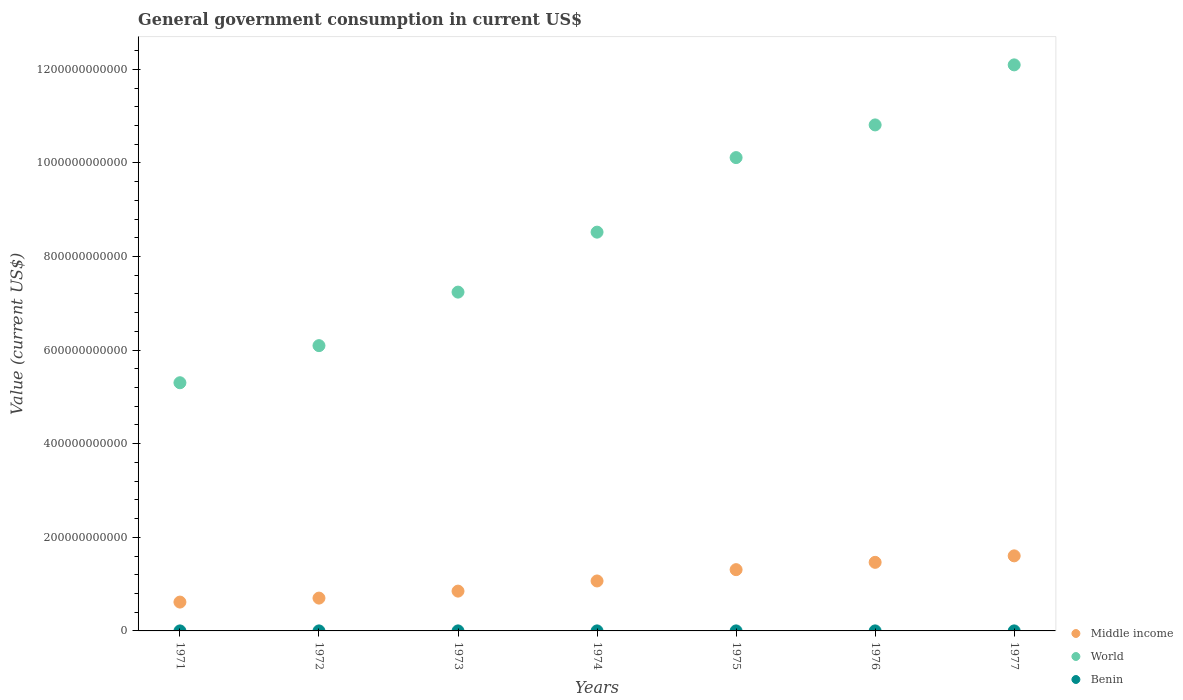How many different coloured dotlines are there?
Provide a short and direct response. 3. What is the government conusmption in Middle income in 1974?
Make the answer very short. 1.07e+11. Across all years, what is the maximum government conusmption in Benin?
Your answer should be very brief. 6.26e+07. Across all years, what is the minimum government conusmption in Middle income?
Give a very brief answer. 6.16e+1. In which year was the government conusmption in Middle income maximum?
Keep it short and to the point. 1977. What is the total government conusmption in World in the graph?
Keep it short and to the point. 6.02e+12. What is the difference between the government conusmption in Benin in 1974 and that in 1976?
Give a very brief answer. -1.22e+07. What is the difference between the government conusmption in Middle income in 1971 and the government conusmption in Benin in 1977?
Offer a very short reply. 6.16e+1. What is the average government conusmption in World per year?
Offer a terse response. 8.60e+11. In the year 1975, what is the difference between the government conusmption in Middle income and government conusmption in World?
Offer a very short reply. -8.80e+11. What is the ratio of the government conusmption in World in 1976 to that in 1977?
Your response must be concise. 0.89. Is the government conusmption in World in 1971 less than that in 1973?
Keep it short and to the point. Yes. What is the difference between the highest and the second highest government conusmption in World?
Make the answer very short. 1.28e+11. What is the difference between the highest and the lowest government conusmption in Benin?
Provide a short and direct response. 2.90e+07. Is the sum of the government conusmption in World in 1974 and 1976 greater than the maximum government conusmption in Middle income across all years?
Your answer should be very brief. Yes. Is it the case that in every year, the sum of the government conusmption in World and government conusmption in Benin  is greater than the government conusmption in Middle income?
Give a very brief answer. Yes. Does the government conusmption in Middle income monotonically increase over the years?
Offer a terse response. Yes. How many years are there in the graph?
Your response must be concise. 7. What is the difference between two consecutive major ticks on the Y-axis?
Your response must be concise. 2.00e+11. Where does the legend appear in the graph?
Offer a very short reply. Bottom right. How many legend labels are there?
Your answer should be compact. 3. How are the legend labels stacked?
Provide a short and direct response. Vertical. What is the title of the graph?
Give a very brief answer. General government consumption in current US$. What is the label or title of the X-axis?
Ensure brevity in your answer.  Years. What is the label or title of the Y-axis?
Ensure brevity in your answer.  Value (current US$). What is the Value (current US$) of Middle income in 1971?
Keep it short and to the point. 6.16e+1. What is the Value (current US$) of World in 1971?
Provide a succinct answer. 5.30e+11. What is the Value (current US$) in Benin in 1971?
Provide a succinct answer. 3.37e+07. What is the Value (current US$) of Middle income in 1972?
Your answer should be very brief. 7.01e+1. What is the Value (current US$) of World in 1972?
Provide a short and direct response. 6.10e+11. What is the Value (current US$) in Benin in 1972?
Ensure brevity in your answer.  4.16e+07. What is the Value (current US$) of Middle income in 1973?
Provide a succinct answer. 8.51e+1. What is the Value (current US$) of World in 1973?
Your answer should be compact. 7.24e+11. What is the Value (current US$) of Benin in 1973?
Your answer should be very brief. 5.02e+07. What is the Value (current US$) of Middle income in 1974?
Offer a very short reply. 1.07e+11. What is the Value (current US$) in World in 1974?
Provide a succinct answer. 8.52e+11. What is the Value (current US$) of Benin in 1974?
Make the answer very short. 4.78e+07. What is the Value (current US$) in Middle income in 1975?
Make the answer very short. 1.31e+11. What is the Value (current US$) in World in 1975?
Offer a terse response. 1.01e+12. What is the Value (current US$) in Benin in 1975?
Your response must be concise. 6.26e+07. What is the Value (current US$) of Middle income in 1976?
Your answer should be very brief. 1.47e+11. What is the Value (current US$) in World in 1976?
Offer a very short reply. 1.08e+12. What is the Value (current US$) of Benin in 1976?
Your answer should be compact. 6.00e+07. What is the Value (current US$) in Middle income in 1977?
Ensure brevity in your answer.  1.60e+11. What is the Value (current US$) in World in 1977?
Offer a very short reply. 1.21e+12. What is the Value (current US$) in Benin in 1977?
Provide a short and direct response. 6.23e+07. Across all years, what is the maximum Value (current US$) of Middle income?
Offer a terse response. 1.60e+11. Across all years, what is the maximum Value (current US$) in World?
Offer a terse response. 1.21e+12. Across all years, what is the maximum Value (current US$) of Benin?
Make the answer very short. 6.26e+07. Across all years, what is the minimum Value (current US$) in Middle income?
Your answer should be very brief. 6.16e+1. Across all years, what is the minimum Value (current US$) in World?
Ensure brevity in your answer.  5.30e+11. Across all years, what is the minimum Value (current US$) in Benin?
Offer a very short reply. 3.37e+07. What is the total Value (current US$) in Middle income in the graph?
Your response must be concise. 7.61e+11. What is the total Value (current US$) in World in the graph?
Provide a succinct answer. 6.02e+12. What is the total Value (current US$) in Benin in the graph?
Offer a terse response. 3.58e+08. What is the difference between the Value (current US$) in Middle income in 1971 and that in 1972?
Ensure brevity in your answer.  -8.50e+09. What is the difference between the Value (current US$) in World in 1971 and that in 1972?
Provide a succinct answer. -7.93e+1. What is the difference between the Value (current US$) in Benin in 1971 and that in 1972?
Keep it short and to the point. -7.96e+06. What is the difference between the Value (current US$) of Middle income in 1971 and that in 1973?
Your answer should be compact. -2.34e+1. What is the difference between the Value (current US$) in World in 1971 and that in 1973?
Offer a terse response. -1.94e+11. What is the difference between the Value (current US$) of Benin in 1971 and that in 1973?
Your response must be concise. -1.66e+07. What is the difference between the Value (current US$) of Middle income in 1971 and that in 1974?
Offer a terse response. -4.51e+1. What is the difference between the Value (current US$) of World in 1971 and that in 1974?
Provide a succinct answer. -3.22e+11. What is the difference between the Value (current US$) of Benin in 1971 and that in 1974?
Your response must be concise. -1.41e+07. What is the difference between the Value (current US$) of Middle income in 1971 and that in 1975?
Make the answer very short. -6.93e+1. What is the difference between the Value (current US$) of World in 1971 and that in 1975?
Your response must be concise. -4.81e+11. What is the difference between the Value (current US$) of Benin in 1971 and that in 1975?
Keep it short and to the point. -2.90e+07. What is the difference between the Value (current US$) in Middle income in 1971 and that in 1976?
Your answer should be compact. -8.49e+1. What is the difference between the Value (current US$) of World in 1971 and that in 1976?
Provide a short and direct response. -5.51e+11. What is the difference between the Value (current US$) in Benin in 1971 and that in 1976?
Your answer should be compact. -2.63e+07. What is the difference between the Value (current US$) in Middle income in 1971 and that in 1977?
Offer a terse response. -9.88e+1. What is the difference between the Value (current US$) in World in 1971 and that in 1977?
Your response must be concise. -6.79e+11. What is the difference between the Value (current US$) in Benin in 1971 and that in 1977?
Ensure brevity in your answer.  -2.87e+07. What is the difference between the Value (current US$) in Middle income in 1972 and that in 1973?
Your answer should be compact. -1.49e+1. What is the difference between the Value (current US$) in World in 1972 and that in 1973?
Your response must be concise. -1.14e+11. What is the difference between the Value (current US$) of Benin in 1972 and that in 1973?
Your answer should be compact. -8.63e+06. What is the difference between the Value (current US$) in Middle income in 1972 and that in 1974?
Provide a succinct answer. -3.66e+1. What is the difference between the Value (current US$) in World in 1972 and that in 1974?
Ensure brevity in your answer.  -2.42e+11. What is the difference between the Value (current US$) in Benin in 1972 and that in 1974?
Provide a succinct answer. -6.15e+06. What is the difference between the Value (current US$) of Middle income in 1972 and that in 1975?
Provide a short and direct response. -6.08e+1. What is the difference between the Value (current US$) in World in 1972 and that in 1975?
Keep it short and to the point. -4.02e+11. What is the difference between the Value (current US$) of Benin in 1972 and that in 1975?
Keep it short and to the point. -2.10e+07. What is the difference between the Value (current US$) of Middle income in 1972 and that in 1976?
Your answer should be very brief. -7.64e+1. What is the difference between the Value (current US$) of World in 1972 and that in 1976?
Provide a succinct answer. -4.72e+11. What is the difference between the Value (current US$) of Benin in 1972 and that in 1976?
Your answer should be compact. -1.84e+07. What is the difference between the Value (current US$) of Middle income in 1972 and that in 1977?
Offer a terse response. -9.03e+1. What is the difference between the Value (current US$) of World in 1972 and that in 1977?
Give a very brief answer. -6.00e+11. What is the difference between the Value (current US$) in Benin in 1972 and that in 1977?
Offer a terse response. -2.07e+07. What is the difference between the Value (current US$) in Middle income in 1973 and that in 1974?
Keep it short and to the point. -2.17e+1. What is the difference between the Value (current US$) of World in 1973 and that in 1974?
Provide a succinct answer. -1.28e+11. What is the difference between the Value (current US$) in Benin in 1973 and that in 1974?
Offer a very short reply. 2.47e+06. What is the difference between the Value (current US$) in Middle income in 1973 and that in 1975?
Your answer should be very brief. -4.59e+1. What is the difference between the Value (current US$) in World in 1973 and that in 1975?
Your answer should be very brief. -2.87e+11. What is the difference between the Value (current US$) of Benin in 1973 and that in 1975?
Give a very brief answer. -1.24e+07. What is the difference between the Value (current US$) of Middle income in 1973 and that in 1976?
Your answer should be very brief. -6.15e+1. What is the difference between the Value (current US$) in World in 1973 and that in 1976?
Give a very brief answer. -3.57e+11. What is the difference between the Value (current US$) in Benin in 1973 and that in 1976?
Keep it short and to the point. -9.76e+06. What is the difference between the Value (current US$) in Middle income in 1973 and that in 1977?
Keep it short and to the point. -7.53e+1. What is the difference between the Value (current US$) in World in 1973 and that in 1977?
Your answer should be compact. -4.86e+11. What is the difference between the Value (current US$) in Benin in 1973 and that in 1977?
Keep it short and to the point. -1.21e+07. What is the difference between the Value (current US$) of Middle income in 1974 and that in 1975?
Offer a terse response. -2.42e+1. What is the difference between the Value (current US$) in World in 1974 and that in 1975?
Give a very brief answer. -1.59e+11. What is the difference between the Value (current US$) in Benin in 1974 and that in 1975?
Give a very brief answer. -1.48e+07. What is the difference between the Value (current US$) of Middle income in 1974 and that in 1976?
Provide a succinct answer. -3.98e+1. What is the difference between the Value (current US$) in World in 1974 and that in 1976?
Give a very brief answer. -2.29e+11. What is the difference between the Value (current US$) of Benin in 1974 and that in 1976?
Give a very brief answer. -1.22e+07. What is the difference between the Value (current US$) of Middle income in 1974 and that in 1977?
Offer a terse response. -5.37e+1. What is the difference between the Value (current US$) in World in 1974 and that in 1977?
Provide a succinct answer. -3.57e+11. What is the difference between the Value (current US$) in Benin in 1974 and that in 1977?
Offer a very short reply. -1.45e+07. What is the difference between the Value (current US$) in Middle income in 1975 and that in 1976?
Make the answer very short. -1.56e+1. What is the difference between the Value (current US$) in World in 1975 and that in 1976?
Your response must be concise. -6.98e+1. What is the difference between the Value (current US$) in Benin in 1975 and that in 1976?
Ensure brevity in your answer.  2.61e+06. What is the difference between the Value (current US$) of Middle income in 1975 and that in 1977?
Keep it short and to the point. -2.95e+1. What is the difference between the Value (current US$) in World in 1975 and that in 1977?
Your answer should be compact. -1.98e+11. What is the difference between the Value (current US$) in Benin in 1975 and that in 1977?
Your answer should be very brief. 3.02e+05. What is the difference between the Value (current US$) of Middle income in 1976 and that in 1977?
Provide a short and direct response. -1.39e+1. What is the difference between the Value (current US$) of World in 1976 and that in 1977?
Your answer should be compact. -1.28e+11. What is the difference between the Value (current US$) of Benin in 1976 and that in 1977?
Offer a very short reply. -2.30e+06. What is the difference between the Value (current US$) in Middle income in 1971 and the Value (current US$) in World in 1972?
Make the answer very short. -5.48e+11. What is the difference between the Value (current US$) in Middle income in 1971 and the Value (current US$) in Benin in 1972?
Give a very brief answer. 6.16e+1. What is the difference between the Value (current US$) in World in 1971 and the Value (current US$) in Benin in 1972?
Keep it short and to the point. 5.30e+11. What is the difference between the Value (current US$) of Middle income in 1971 and the Value (current US$) of World in 1973?
Your answer should be very brief. -6.62e+11. What is the difference between the Value (current US$) in Middle income in 1971 and the Value (current US$) in Benin in 1973?
Provide a short and direct response. 6.16e+1. What is the difference between the Value (current US$) of World in 1971 and the Value (current US$) of Benin in 1973?
Provide a succinct answer. 5.30e+11. What is the difference between the Value (current US$) of Middle income in 1971 and the Value (current US$) of World in 1974?
Offer a very short reply. -7.90e+11. What is the difference between the Value (current US$) of Middle income in 1971 and the Value (current US$) of Benin in 1974?
Offer a terse response. 6.16e+1. What is the difference between the Value (current US$) of World in 1971 and the Value (current US$) of Benin in 1974?
Offer a terse response. 5.30e+11. What is the difference between the Value (current US$) in Middle income in 1971 and the Value (current US$) in World in 1975?
Make the answer very short. -9.50e+11. What is the difference between the Value (current US$) in Middle income in 1971 and the Value (current US$) in Benin in 1975?
Provide a succinct answer. 6.16e+1. What is the difference between the Value (current US$) of World in 1971 and the Value (current US$) of Benin in 1975?
Provide a short and direct response. 5.30e+11. What is the difference between the Value (current US$) of Middle income in 1971 and the Value (current US$) of World in 1976?
Your response must be concise. -1.02e+12. What is the difference between the Value (current US$) in Middle income in 1971 and the Value (current US$) in Benin in 1976?
Provide a short and direct response. 6.16e+1. What is the difference between the Value (current US$) of World in 1971 and the Value (current US$) of Benin in 1976?
Ensure brevity in your answer.  5.30e+11. What is the difference between the Value (current US$) in Middle income in 1971 and the Value (current US$) in World in 1977?
Your answer should be compact. -1.15e+12. What is the difference between the Value (current US$) of Middle income in 1971 and the Value (current US$) of Benin in 1977?
Your response must be concise. 6.16e+1. What is the difference between the Value (current US$) in World in 1971 and the Value (current US$) in Benin in 1977?
Provide a short and direct response. 5.30e+11. What is the difference between the Value (current US$) in Middle income in 1972 and the Value (current US$) in World in 1973?
Your answer should be very brief. -6.54e+11. What is the difference between the Value (current US$) of Middle income in 1972 and the Value (current US$) of Benin in 1973?
Give a very brief answer. 7.01e+1. What is the difference between the Value (current US$) in World in 1972 and the Value (current US$) in Benin in 1973?
Give a very brief answer. 6.10e+11. What is the difference between the Value (current US$) of Middle income in 1972 and the Value (current US$) of World in 1974?
Offer a very short reply. -7.82e+11. What is the difference between the Value (current US$) of Middle income in 1972 and the Value (current US$) of Benin in 1974?
Your response must be concise. 7.01e+1. What is the difference between the Value (current US$) of World in 1972 and the Value (current US$) of Benin in 1974?
Offer a very short reply. 6.10e+11. What is the difference between the Value (current US$) of Middle income in 1972 and the Value (current US$) of World in 1975?
Ensure brevity in your answer.  -9.41e+11. What is the difference between the Value (current US$) in Middle income in 1972 and the Value (current US$) in Benin in 1975?
Your response must be concise. 7.01e+1. What is the difference between the Value (current US$) in World in 1972 and the Value (current US$) in Benin in 1975?
Keep it short and to the point. 6.09e+11. What is the difference between the Value (current US$) of Middle income in 1972 and the Value (current US$) of World in 1976?
Provide a succinct answer. -1.01e+12. What is the difference between the Value (current US$) in Middle income in 1972 and the Value (current US$) in Benin in 1976?
Keep it short and to the point. 7.01e+1. What is the difference between the Value (current US$) in World in 1972 and the Value (current US$) in Benin in 1976?
Your answer should be compact. 6.09e+11. What is the difference between the Value (current US$) of Middle income in 1972 and the Value (current US$) of World in 1977?
Provide a succinct answer. -1.14e+12. What is the difference between the Value (current US$) in Middle income in 1972 and the Value (current US$) in Benin in 1977?
Your answer should be compact. 7.01e+1. What is the difference between the Value (current US$) in World in 1972 and the Value (current US$) in Benin in 1977?
Keep it short and to the point. 6.09e+11. What is the difference between the Value (current US$) in Middle income in 1973 and the Value (current US$) in World in 1974?
Give a very brief answer. -7.67e+11. What is the difference between the Value (current US$) in Middle income in 1973 and the Value (current US$) in Benin in 1974?
Give a very brief answer. 8.50e+1. What is the difference between the Value (current US$) in World in 1973 and the Value (current US$) in Benin in 1974?
Your response must be concise. 7.24e+11. What is the difference between the Value (current US$) of Middle income in 1973 and the Value (current US$) of World in 1975?
Provide a short and direct response. -9.26e+11. What is the difference between the Value (current US$) of Middle income in 1973 and the Value (current US$) of Benin in 1975?
Your answer should be compact. 8.50e+1. What is the difference between the Value (current US$) in World in 1973 and the Value (current US$) in Benin in 1975?
Ensure brevity in your answer.  7.24e+11. What is the difference between the Value (current US$) in Middle income in 1973 and the Value (current US$) in World in 1976?
Provide a succinct answer. -9.96e+11. What is the difference between the Value (current US$) in Middle income in 1973 and the Value (current US$) in Benin in 1976?
Give a very brief answer. 8.50e+1. What is the difference between the Value (current US$) of World in 1973 and the Value (current US$) of Benin in 1976?
Keep it short and to the point. 7.24e+11. What is the difference between the Value (current US$) of Middle income in 1973 and the Value (current US$) of World in 1977?
Keep it short and to the point. -1.12e+12. What is the difference between the Value (current US$) in Middle income in 1973 and the Value (current US$) in Benin in 1977?
Provide a succinct answer. 8.50e+1. What is the difference between the Value (current US$) in World in 1973 and the Value (current US$) in Benin in 1977?
Your answer should be very brief. 7.24e+11. What is the difference between the Value (current US$) in Middle income in 1974 and the Value (current US$) in World in 1975?
Offer a very short reply. -9.05e+11. What is the difference between the Value (current US$) of Middle income in 1974 and the Value (current US$) of Benin in 1975?
Offer a very short reply. 1.07e+11. What is the difference between the Value (current US$) of World in 1974 and the Value (current US$) of Benin in 1975?
Your response must be concise. 8.52e+11. What is the difference between the Value (current US$) of Middle income in 1974 and the Value (current US$) of World in 1976?
Keep it short and to the point. -9.74e+11. What is the difference between the Value (current US$) of Middle income in 1974 and the Value (current US$) of Benin in 1976?
Ensure brevity in your answer.  1.07e+11. What is the difference between the Value (current US$) in World in 1974 and the Value (current US$) in Benin in 1976?
Your response must be concise. 8.52e+11. What is the difference between the Value (current US$) in Middle income in 1974 and the Value (current US$) in World in 1977?
Ensure brevity in your answer.  -1.10e+12. What is the difference between the Value (current US$) of Middle income in 1974 and the Value (current US$) of Benin in 1977?
Keep it short and to the point. 1.07e+11. What is the difference between the Value (current US$) of World in 1974 and the Value (current US$) of Benin in 1977?
Provide a short and direct response. 8.52e+11. What is the difference between the Value (current US$) of Middle income in 1975 and the Value (current US$) of World in 1976?
Make the answer very short. -9.50e+11. What is the difference between the Value (current US$) in Middle income in 1975 and the Value (current US$) in Benin in 1976?
Give a very brief answer. 1.31e+11. What is the difference between the Value (current US$) in World in 1975 and the Value (current US$) in Benin in 1976?
Your answer should be very brief. 1.01e+12. What is the difference between the Value (current US$) in Middle income in 1975 and the Value (current US$) in World in 1977?
Your answer should be very brief. -1.08e+12. What is the difference between the Value (current US$) of Middle income in 1975 and the Value (current US$) of Benin in 1977?
Provide a succinct answer. 1.31e+11. What is the difference between the Value (current US$) of World in 1975 and the Value (current US$) of Benin in 1977?
Provide a succinct answer. 1.01e+12. What is the difference between the Value (current US$) of Middle income in 1976 and the Value (current US$) of World in 1977?
Keep it short and to the point. -1.06e+12. What is the difference between the Value (current US$) in Middle income in 1976 and the Value (current US$) in Benin in 1977?
Your response must be concise. 1.46e+11. What is the difference between the Value (current US$) of World in 1976 and the Value (current US$) of Benin in 1977?
Provide a short and direct response. 1.08e+12. What is the average Value (current US$) of Middle income per year?
Give a very brief answer. 1.09e+11. What is the average Value (current US$) in World per year?
Ensure brevity in your answer.  8.60e+11. What is the average Value (current US$) in Benin per year?
Offer a very short reply. 5.12e+07. In the year 1971, what is the difference between the Value (current US$) in Middle income and Value (current US$) in World?
Make the answer very short. -4.69e+11. In the year 1971, what is the difference between the Value (current US$) in Middle income and Value (current US$) in Benin?
Offer a terse response. 6.16e+1. In the year 1971, what is the difference between the Value (current US$) of World and Value (current US$) of Benin?
Your answer should be very brief. 5.30e+11. In the year 1972, what is the difference between the Value (current US$) in Middle income and Value (current US$) in World?
Your response must be concise. -5.39e+11. In the year 1972, what is the difference between the Value (current US$) in Middle income and Value (current US$) in Benin?
Keep it short and to the point. 7.01e+1. In the year 1972, what is the difference between the Value (current US$) in World and Value (current US$) in Benin?
Your answer should be compact. 6.10e+11. In the year 1973, what is the difference between the Value (current US$) in Middle income and Value (current US$) in World?
Provide a succinct answer. -6.39e+11. In the year 1973, what is the difference between the Value (current US$) of Middle income and Value (current US$) of Benin?
Your response must be concise. 8.50e+1. In the year 1973, what is the difference between the Value (current US$) in World and Value (current US$) in Benin?
Offer a very short reply. 7.24e+11. In the year 1974, what is the difference between the Value (current US$) in Middle income and Value (current US$) in World?
Ensure brevity in your answer.  -7.45e+11. In the year 1974, what is the difference between the Value (current US$) in Middle income and Value (current US$) in Benin?
Your answer should be compact. 1.07e+11. In the year 1974, what is the difference between the Value (current US$) of World and Value (current US$) of Benin?
Offer a very short reply. 8.52e+11. In the year 1975, what is the difference between the Value (current US$) of Middle income and Value (current US$) of World?
Give a very brief answer. -8.80e+11. In the year 1975, what is the difference between the Value (current US$) of Middle income and Value (current US$) of Benin?
Offer a terse response. 1.31e+11. In the year 1975, what is the difference between the Value (current US$) in World and Value (current US$) in Benin?
Offer a very short reply. 1.01e+12. In the year 1976, what is the difference between the Value (current US$) of Middle income and Value (current US$) of World?
Provide a short and direct response. -9.35e+11. In the year 1976, what is the difference between the Value (current US$) of Middle income and Value (current US$) of Benin?
Offer a very short reply. 1.46e+11. In the year 1976, what is the difference between the Value (current US$) in World and Value (current US$) in Benin?
Provide a short and direct response. 1.08e+12. In the year 1977, what is the difference between the Value (current US$) of Middle income and Value (current US$) of World?
Offer a terse response. -1.05e+12. In the year 1977, what is the difference between the Value (current US$) in Middle income and Value (current US$) in Benin?
Make the answer very short. 1.60e+11. In the year 1977, what is the difference between the Value (current US$) in World and Value (current US$) in Benin?
Offer a very short reply. 1.21e+12. What is the ratio of the Value (current US$) in Middle income in 1971 to that in 1972?
Offer a terse response. 0.88. What is the ratio of the Value (current US$) in World in 1971 to that in 1972?
Give a very brief answer. 0.87. What is the ratio of the Value (current US$) of Benin in 1971 to that in 1972?
Your response must be concise. 0.81. What is the ratio of the Value (current US$) of Middle income in 1971 to that in 1973?
Ensure brevity in your answer.  0.72. What is the ratio of the Value (current US$) in World in 1971 to that in 1973?
Give a very brief answer. 0.73. What is the ratio of the Value (current US$) in Benin in 1971 to that in 1973?
Give a very brief answer. 0.67. What is the ratio of the Value (current US$) of Middle income in 1971 to that in 1974?
Offer a very short reply. 0.58. What is the ratio of the Value (current US$) in World in 1971 to that in 1974?
Your answer should be compact. 0.62. What is the ratio of the Value (current US$) of Benin in 1971 to that in 1974?
Keep it short and to the point. 0.7. What is the ratio of the Value (current US$) in Middle income in 1971 to that in 1975?
Offer a very short reply. 0.47. What is the ratio of the Value (current US$) of World in 1971 to that in 1975?
Your answer should be compact. 0.52. What is the ratio of the Value (current US$) of Benin in 1971 to that in 1975?
Keep it short and to the point. 0.54. What is the ratio of the Value (current US$) in Middle income in 1971 to that in 1976?
Keep it short and to the point. 0.42. What is the ratio of the Value (current US$) of World in 1971 to that in 1976?
Give a very brief answer. 0.49. What is the ratio of the Value (current US$) of Benin in 1971 to that in 1976?
Your response must be concise. 0.56. What is the ratio of the Value (current US$) of Middle income in 1971 to that in 1977?
Your response must be concise. 0.38. What is the ratio of the Value (current US$) in World in 1971 to that in 1977?
Give a very brief answer. 0.44. What is the ratio of the Value (current US$) of Benin in 1971 to that in 1977?
Offer a very short reply. 0.54. What is the ratio of the Value (current US$) in Middle income in 1972 to that in 1973?
Keep it short and to the point. 0.82. What is the ratio of the Value (current US$) in World in 1972 to that in 1973?
Provide a succinct answer. 0.84. What is the ratio of the Value (current US$) of Benin in 1972 to that in 1973?
Your response must be concise. 0.83. What is the ratio of the Value (current US$) in Middle income in 1972 to that in 1974?
Your response must be concise. 0.66. What is the ratio of the Value (current US$) of World in 1972 to that in 1974?
Your answer should be very brief. 0.72. What is the ratio of the Value (current US$) in Benin in 1972 to that in 1974?
Make the answer very short. 0.87. What is the ratio of the Value (current US$) in Middle income in 1972 to that in 1975?
Give a very brief answer. 0.54. What is the ratio of the Value (current US$) of World in 1972 to that in 1975?
Your answer should be very brief. 0.6. What is the ratio of the Value (current US$) of Benin in 1972 to that in 1975?
Provide a succinct answer. 0.66. What is the ratio of the Value (current US$) of Middle income in 1972 to that in 1976?
Your answer should be very brief. 0.48. What is the ratio of the Value (current US$) in World in 1972 to that in 1976?
Make the answer very short. 0.56. What is the ratio of the Value (current US$) in Benin in 1972 to that in 1976?
Make the answer very short. 0.69. What is the ratio of the Value (current US$) of Middle income in 1972 to that in 1977?
Offer a very short reply. 0.44. What is the ratio of the Value (current US$) of World in 1972 to that in 1977?
Offer a terse response. 0.5. What is the ratio of the Value (current US$) in Benin in 1972 to that in 1977?
Your answer should be very brief. 0.67. What is the ratio of the Value (current US$) of Middle income in 1973 to that in 1974?
Make the answer very short. 0.8. What is the ratio of the Value (current US$) in World in 1973 to that in 1974?
Your answer should be compact. 0.85. What is the ratio of the Value (current US$) in Benin in 1973 to that in 1974?
Your response must be concise. 1.05. What is the ratio of the Value (current US$) of Middle income in 1973 to that in 1975?
Provide a short and direct response. 0.65. What is the ratio of the Value (current US$) of World in 1973 to that in 1975?
Provide a short and direct response. 0.72. What is the ratio of the Value (current US$) in Benin in 1973 to that in 1975?
Make the answer very short. 0.8. What is the ratio of the Value (current US$) in Middle income in 1973 to that in 1976?
Offer a very short reply. 0.58. What is the ratio of the Value (current US$) in World in 1973 to that in 1976?
Your answer should be very brief. 0.67. What is the ratio of the Value (current US$) of Benin in 1973 to that in 1976?
Keep it short and to the point. 0.84. What is the ratio of the Value (current US$) of Middle income in 1973 to that in 1977?
Give a very brief answer. 0.53. What is the ratio of the Value (current US$) of World in 1973 to that in 1977?
Offer a very short reply. 0.6. What is the ratio of the Value (current US$) in Benin in 1973 to that in 1977?
Ensure brevity in your answer.  0.81. What is the ratio of the Value (current US$) in Middle income in 1974 to that in 1975?
Your answer should be compact. 0.82. What is the ratio of the Value (current US$) of World in 1974 to that in 1975?
Make the answer very short. 0.84. What is the ratio of the Value (current US$) in Benin in 1974 to that in 1975?
Provide a succinct answer. 0.76. What is the ratio of the Value (current US$) in Middle income in 1974 to that in 1976?
Provide a short and direct response. 0.73. What is the ratio of the Value (current US$) of World in 1974 to that in 1976?
Ensure brevity in your answer.  0.79. What is the ratio of the Value (current US$) of Benin in 1974 to that in 1976?
Make the answer very short. 0.8. What is the ratio of the Value (current US$) of Middle income in 1974 to that in 1977?
Provide a succinct answer. 0.67. What is the ratio of the Value (current US$) of World in 1974 to that in 1977?
Offer a terse response. 0.7. What is the ratio of the Value (current US$) in Benin in 1974 to that in 1977?
Your answer should be very brief. 0.77. What is the ratio of the Value (current US$) of Middle income in 1975 to that in 1976?
Your answer should be very brief. 0.89. What is the ratio of the Value (current US$) of World in 1975 to that in 1976?
Your answer should be compact. 0.94. What is the ratio of the Value (current US$) of Benin in 1975 to that in 1976?
Keep it short and to the point. 1.04. What is the ratio of the Value (current US$) of Middle income in 1975 to that in 1977?
Provide a succinct answer. 0.82. What is the ratio of the Value (current US$) in World in 1975 to that in 1977?
Offer a very short reply. 0.84. What is the ratio of the Value (current US$) of Benin in 1975 to that in 1977?
Your answer should be compact. 1. What is the ratio of the Value (current US$) in Middle income in 1976 to that in 1977?
Your response must be concise. 0.91. What is the ratio of the Value (current US$) in World in 1976 to that in 1977?
Ensure brevity in your answer.  0.89. What is the ratio of the Value (current US$) of Benin in 1976 to that in 1977?
Give a very brief answer. 0.96. What is the difference between the highest and the second highest Value (current US$) of Middle income?
Keep it short and to the point. 1.39e+1. What is the difference between the highest and the second highest Value (current US$) in World?
Make the answer very short. 1.28e+11. What is the difference between the highest and the second highest Value (current US$) in Benin?
Offer a terse response. 3.02e+05. What is the difference between the highest and the lowest Value (current US$) in Middle income?
Your answer should be very brief. 9.88e+1. What is the difference between the highest and the lowest Value (current US$) in World?
Provide a short and direct response. 6.79e+11. What is the difference between the highest and the lowest Value (current US$) of Benin?
Provide a succinct answer. 2.90e+07. 